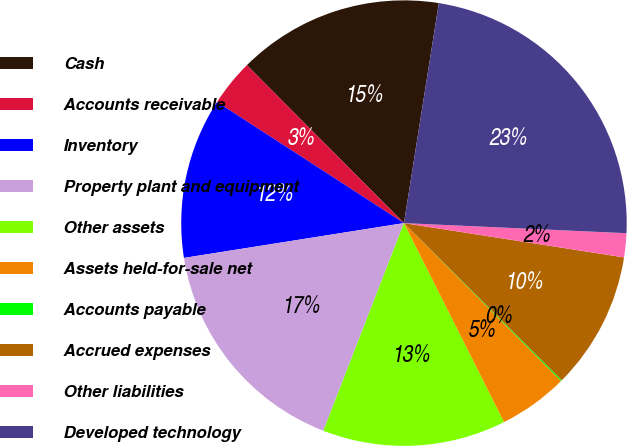Convert chart. <chart><loc_0><loc_0><loc_500><loc_500><pie_chart><fcel>Cash<fcel>Accounts receivable<fcel>Inventory<fcel>Property plant and equipment<fcel>Other assets<fcel>Assets held-for-sale net<fcel>Accounts payable<fcel>Accrued expenses<fcel>Other liabilities<fcel>Developed technology<nl><fcel>14.96%<fcel>3.39%<fcel>11.65%<fcel>16.61%<fcel>13.31%<fcel>5.04%<fcel>0.08%<fcel>10.0%<fcel>1.74%<fcel>23.22%<nl></chart> 